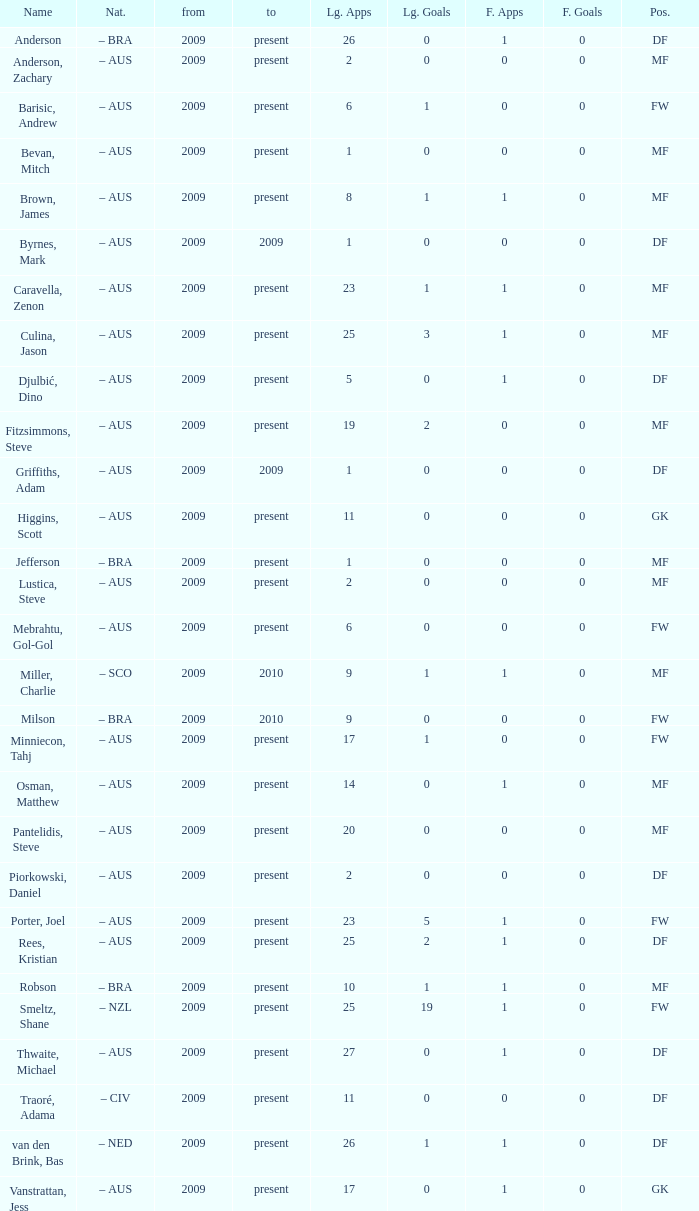Specify the job title for van den brink, bas DF. 